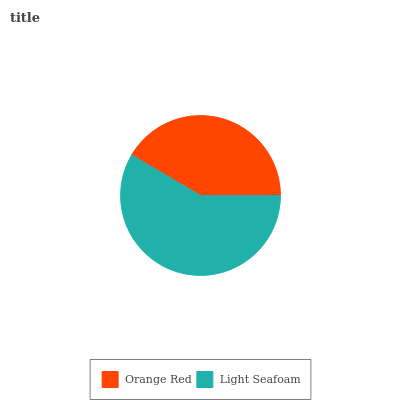Is Orange Red the minimum?
Answer yes or no. Yes. Is Light Seafoam the maximum?
Answer yes or no. Yes. Is Light Seafoam the minimum?
Answer yes or no. No. Is Light Seafoam greater than Orange Red?
Answer yes or no. Yes. Is Orange Red less than Light Seafoam?
Answer yes or no. Yes. Is Orange Red greater than Light Seafoam?
Answer yes or no. No. Is Light Seafoam less than Orange Red?
Answer yes or no. No. Is Light Seafoam the high median?
Answer yes or no. Yes. Is Orange Red the low median?
Answer yes or no. Yes. Is Orange Red the high median?
Answer yes or no. No. Is Light Seafoam the low median?
Answer yes or no. No. 